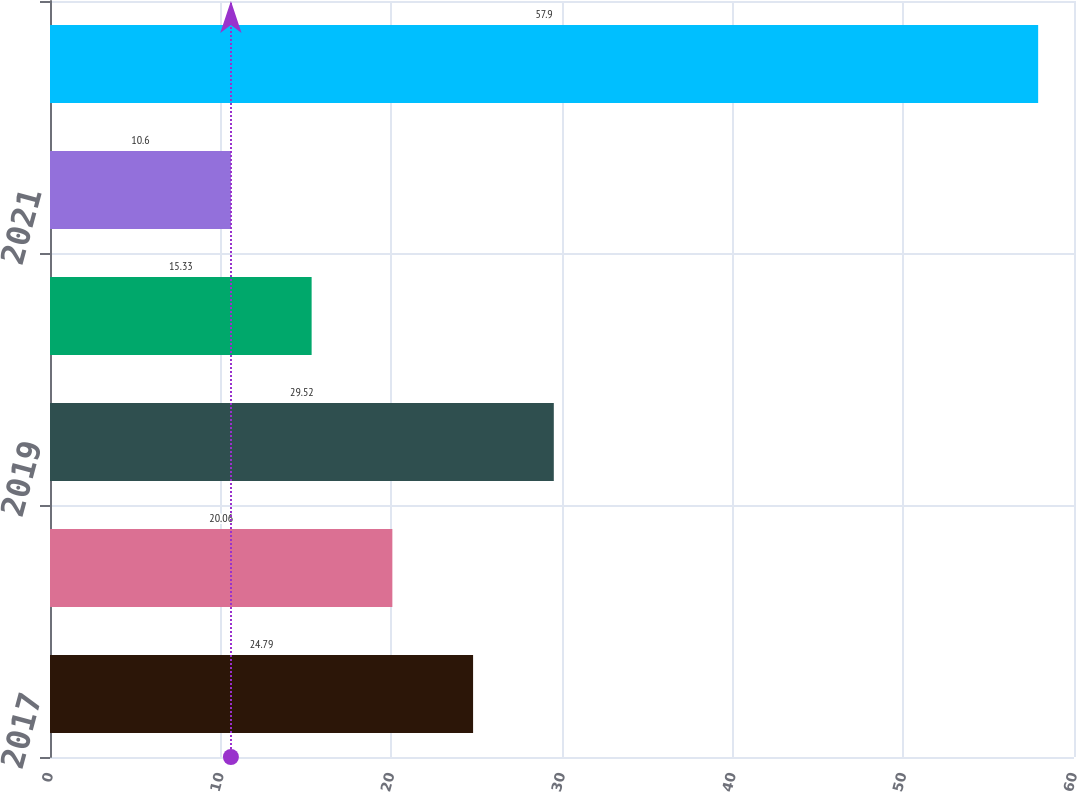Convert chart to OTSL. <chart><loc_0><loc_0><loc_500><loc_500><bar_chart><fcel>2017<fcel>2018<fcel>2019<fcel>2020<fcel>2021<fcel>2022-2026<nl><fcel>24.79<fcel>20.06<fcel>29.52<fcel>15.33<fcel>10.6<fcel>57.9<nl></chart> 